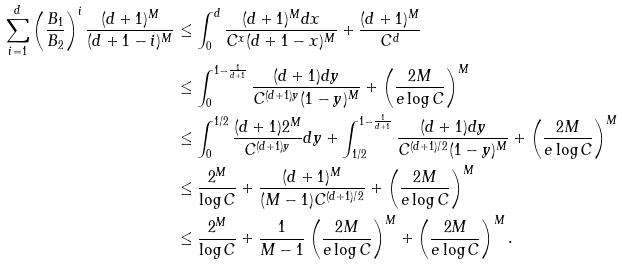Convert formula to latex. <formula><loc_0><loc_0><loc_500><loc_500>\sum _ { i = 1 } ^ { d } \left ( \frac { B _ { 1 } } { B _ { 2 } } \right ) ^ { i } \frac { ( d + 1 ) ^ { M } } { ( d + 1 - i ) ^ { M } } & \leq \int _ { 0 } ^ { d } \frac { ( d + 1 ) ^ { M } d x } { C ^ { x } ( d + 1 - x ) ^ { M } } + \frac { ( d + 1 ) ^ { M } } { C ^ { d } } \\ & \leq \int _ { 0 } ^ { 1 - \frac { 1 } { d + 1 } } \frac { ( d + 1 ) d y } { C ^ { ( d + 1 ) y } ( 1 - y ) ^ { M } } + \left ( \frac { 2 M } { e \log C } \right ) ^ { M } \\ & \leq \int _ { 0 } ^ { 1 / 2 } \frac { ( d + 1 ) 2 ^ { M } } { C ^ { ( d + 1 ) y } } d y + \int _ { 1 / 2 } ^ { 1 - \frac { 1 } { d + 1 } } \frac { ( d + 1 ) d y } { C ^ { ( d + 1 ) / 2 } ( 1 - y ) ^ { M } } + \left ( \frac { 2 M } { e \log C } \right ) ^ { M } \\ & \leq \frac { 2 ^ { M } } { \log C } + \frac { ( d + 1 ) ^ { M } } { ( M - 1 ) C ^ { ( d + 1 ) / 2 } } + \left ( \frac { 2 M } { e \log C } \right ) ^ { M } \\ & \leq \frac { 2 ^ { M } } { \log C } + \frac { 1 } { M - 1 } \left ( \frac { 2 M } { e \log C } \right ) ^ { M } + \left ( \frac { 2 M } { e \log C } \right ) ^ { M } .</formula> 